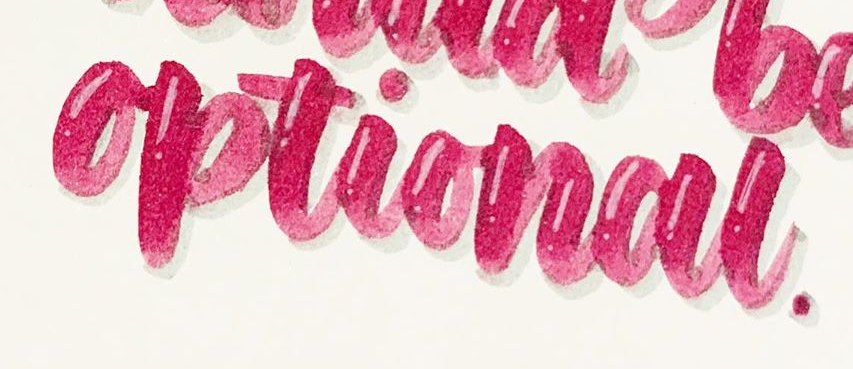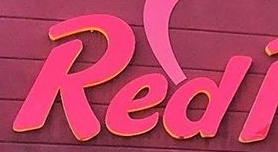What words can you see in these images in sequence, separated by a semicolon? optional; Red 